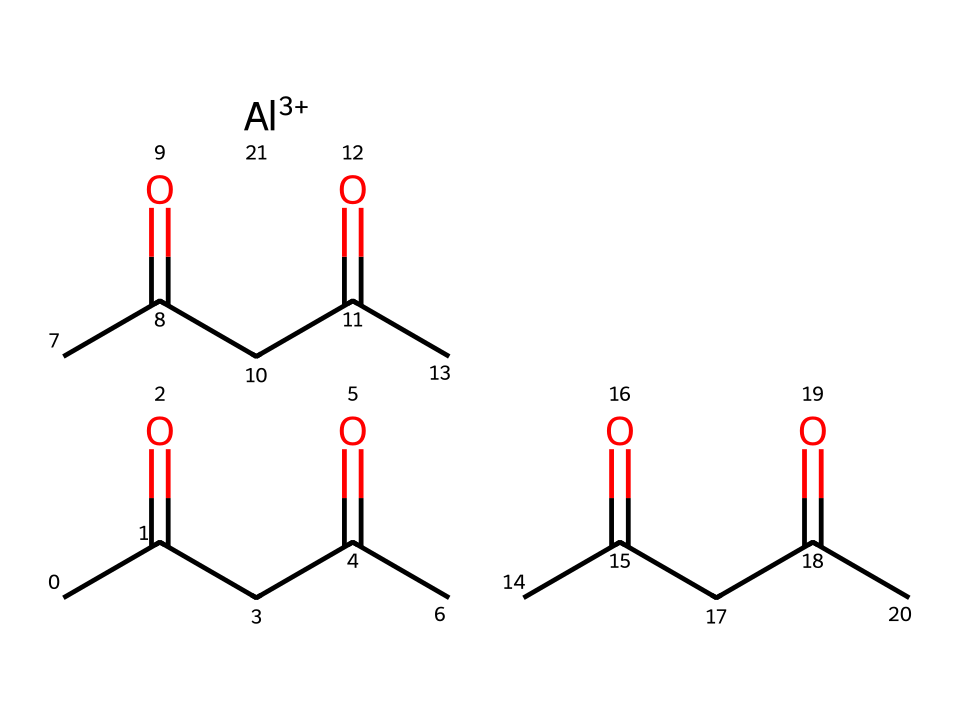What is the central metal atom in aluminum acetylacetonate? The SMILES representation clearly indicates the presence of an aluminum ion denoted by [Al+3], which is the central metal atom in the compound.
Answer: aluminum How many acetylacetonate ligands are bound to the aluminum atom? The structure shows three acetylacetonate units connected to the aluminum. Each acetylacetonate contributes to the coordination around the aluminum atom, confirming there are three.
Answer: three What type of bonding is mainly present in aluminum acetylacetonate? The primary bonding in this organometallic compound is coordination bonding between the aluminum metal and the oxygen atoms of the acetylacetonate ligands, characteristic of organometallic compounds.
Answer: coordination What is the functional group present in the ligands of aluminum acetylacetonate? The acetylacetonate ligands contain a diketone functional group due to the presence of two carbonyl groups (C=O) in each ligand, which are central to their structure.
Answer: diketone How many total carbon atoms are present in the aluminum acetylacetonate structure? The SMILES notation indicates three acetylacetonate units, each containing five carbon atoms, which results in a total of fifteen carbon atoms in the entire molecule.
Answer: fifteen In what industry is aluminum acetylacetonate primarily used? The compound is primarily utilized in the film production industry, especially for creating reflective surfaces in lighting equipment to enhance efficiency and brightness.
Answer: film production 